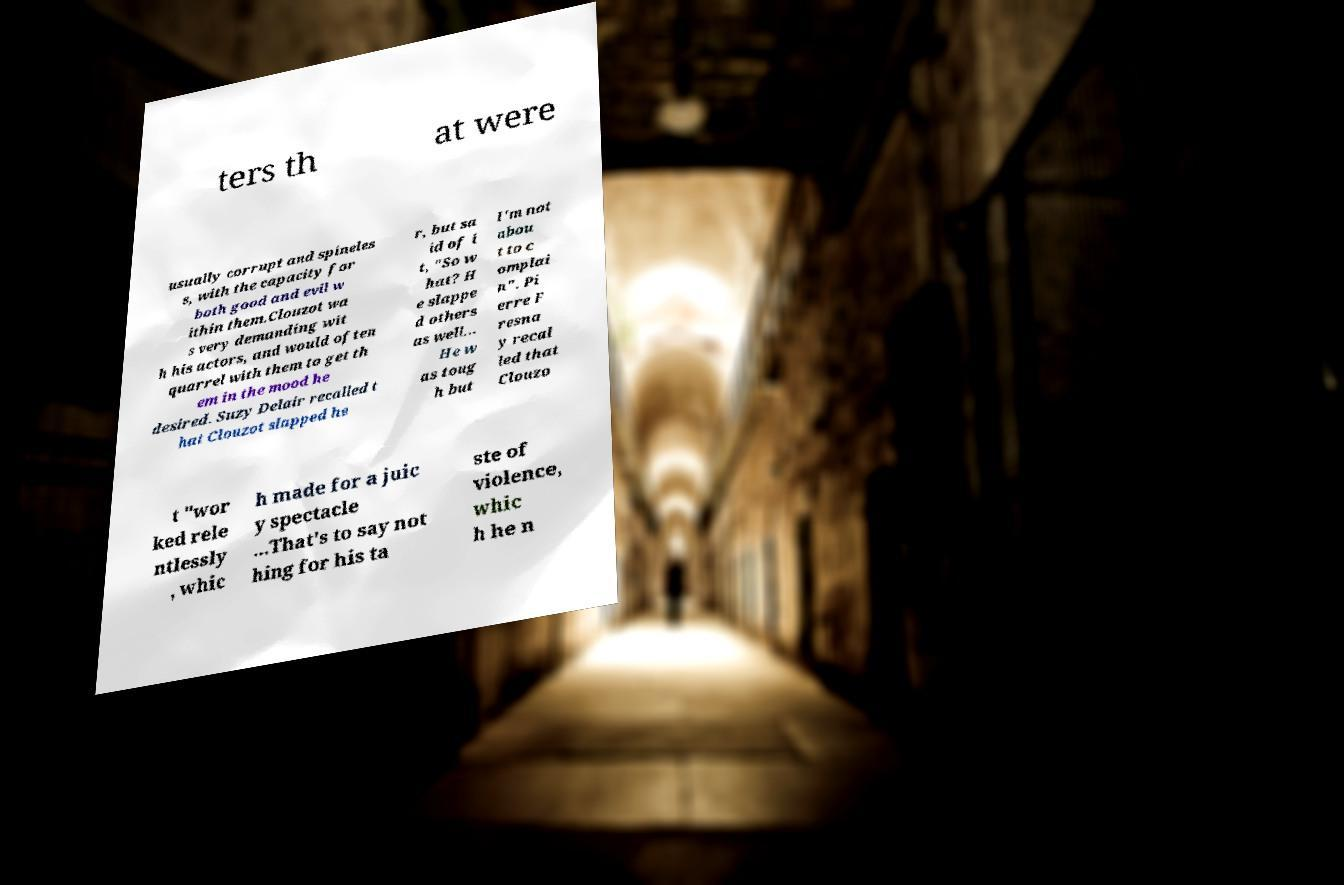There's text embedded in this image that I need extracted. Can you transcribe it verbatim? ters th at were usually corrupt and spineles s, with the capacity for both good and evil w ithin them.Clouzot wa s very demanding wit h his actors, and would often quarrel with them to get th em in the mood he desired. Suzy Delair recalled t hat Clouzot slapped he r, but sa id of i t, "So w hat? H e slappe d others as well... He w as toug h but I'm not abou t to c omplai n". Pi erre F resna y recal led that Clouzo t "wor ked rele ntlessly , whic h made for a juic y spectacle ...That's to say not hing for his ta ste of violence, whic h he n 